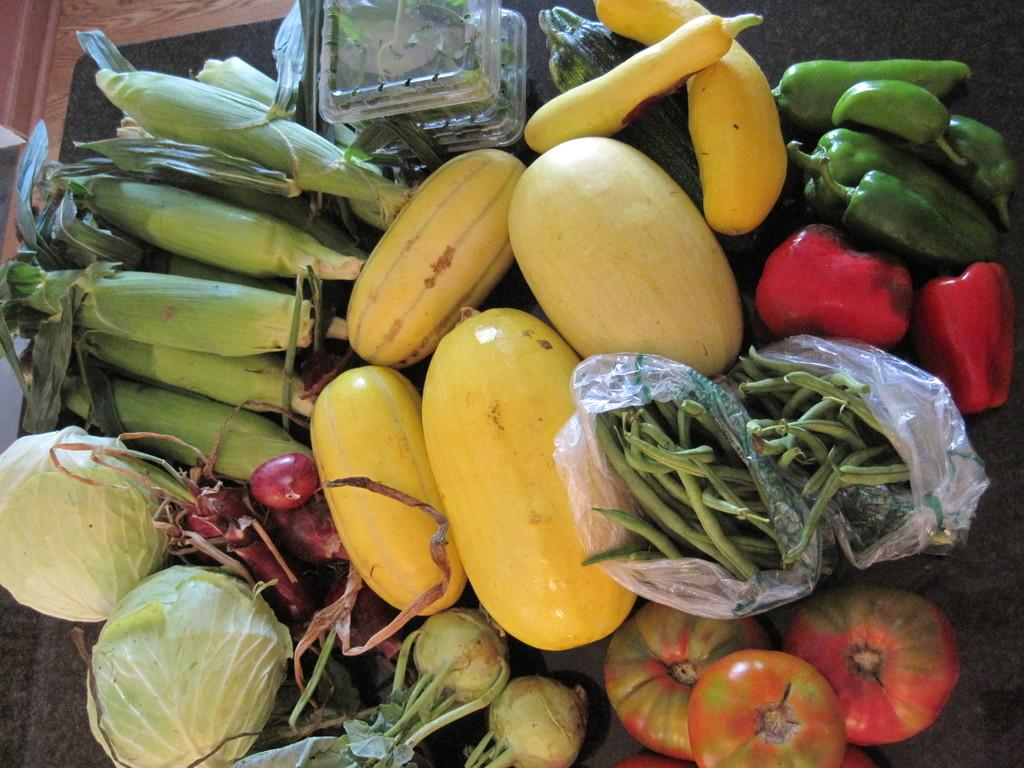What type of food items can be seen in the image? There are beans, tomatoes, radish, cabbage, corn, and capsicum in the image. Where are the vegetables placed in the image? All the vegetables are placed on a table. What type of toy can be seen playing with the vegetables in the image? There is no toy present in the image, and the vegetables are not being played with. 